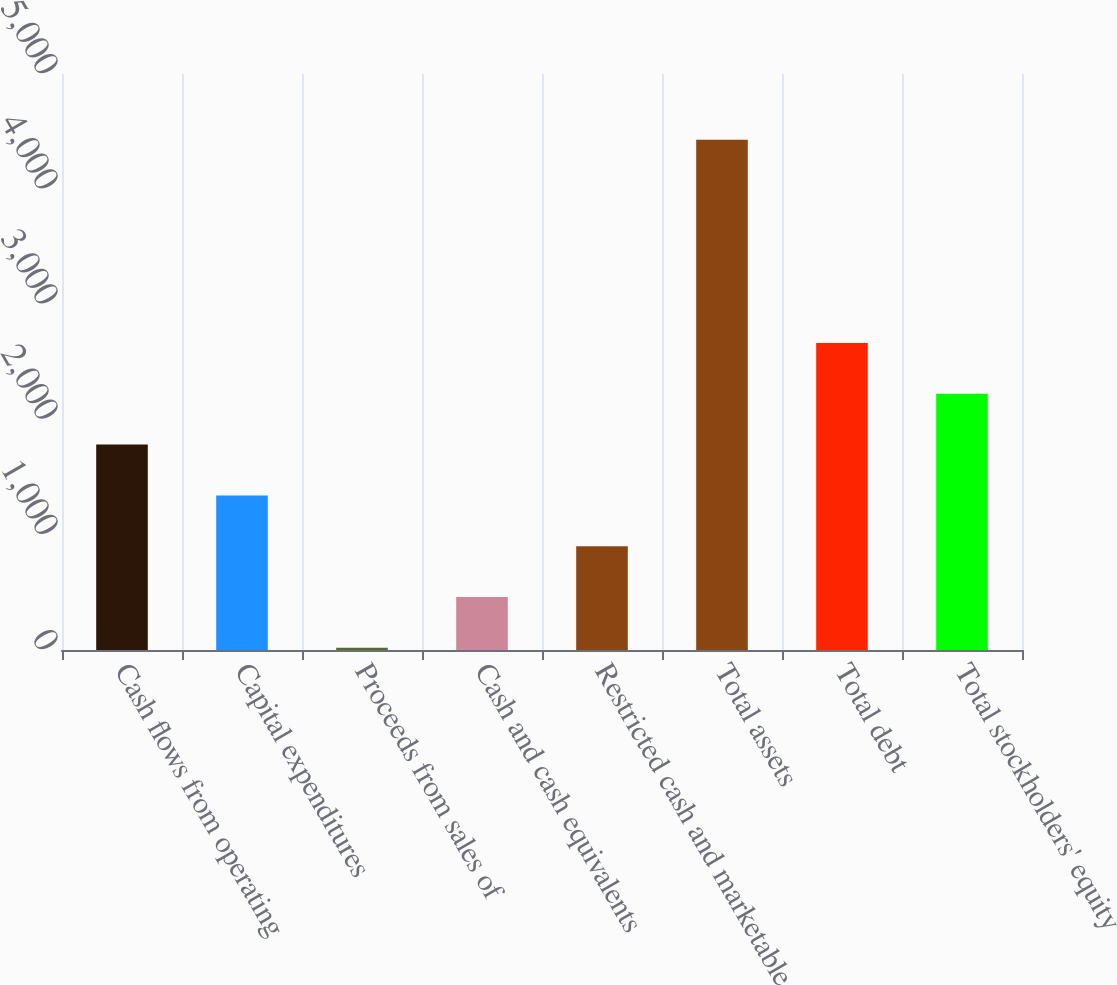<chart> <loc_0><loc_0><loc_500><loc_500><bar_chart><fcel>Cash flows from operating<fcel>Capital expenditures<fcel>Proceeds from sales of<fcel>Cash and cash equivalents<fcel>Restricted cash and marketable<fcel>Total assets<fcel>Total debt<fcel>Total stockholders' equity<nl><fcel>1782.86<fcel>1341.77<fcel>18.5<fcel>459.59<fcel>900.68<fcel>4429.4<fcel>2665.04<fcel>2223.95<nl></chart> 